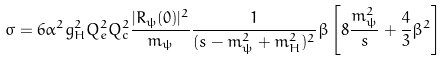<formula> <loc_0><loc_0><loc_500><loc_500>\sigma = 6 \alpha ^ { 2 } g _ { H } ^ { 2 } Q _ { e } ^ { 2 } Q _ { c } ^ { 2 } \frac { | R _ { \psi } ( 0 ) | ^ { 2 } } { m _ { \psi } } \frac { 1 } { ( s - m _ { \psi } ^ { 2 } + m _ { H } ^ { 2 } ) ^ { 2 } } \beta \left [ 8 \frac { m _ { \psi } ^ { 2 } } { s } + \frac { 4 } { 3 } \beta ^ { 2 } \right ]</formula> 